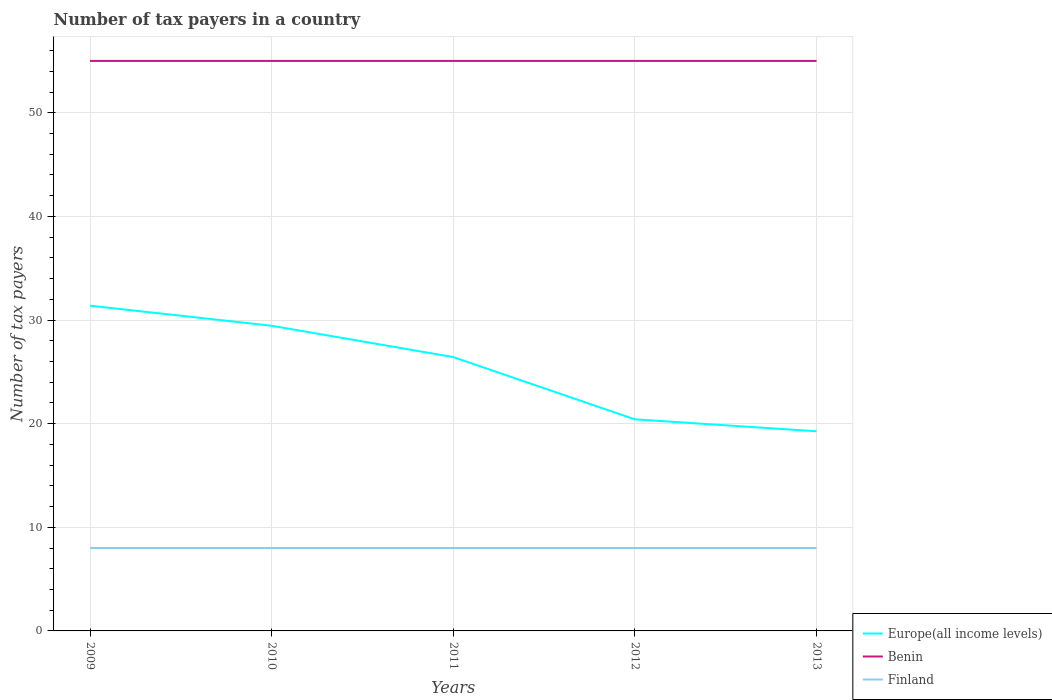How many different coloured lines are there?
Make the answer very short. 3. Across all years, what is the maximum number of tax payers in in Finland?
Give a very brief answer. 8. In which year was the number of tax payers in in Europe(all income levels) maximum?
Ensure brevity in your answer.  2013. What is the total number of tax payers in in Finland in the graph?
Provide a short and direct response. 0. Is the number of tax payers in in Benin strictly greater than the number of tax payers in in Finland over the years?
Make the answer very short. No. How many lines are there?
Ensure brevity in your answer.  3. How many years are there in the graph?
Offer a terse response. 5. Does the graph contain any zero values?
Make the answer very short. No. Does the graph contain grids?
Your response must be concise. Yes. How many legend labels are there?
Ensure brevity in your answer.  3. What is the title of the graph?
Your answer should be very brief. Number of tax payers in a country. What is the label or title of the X-axis?
Give a very brief answer. Years. What is the label or title of the Y-axis?
Keep it short and to the point. Number of tax payers. What is the Number of tax payers in Europe(all income levels) in 2009?
Make the answer very short. 31.38. What is the Number of tax payers of Benin in 2009?
Your answer should be very brief. 55. What is the Number of tax payers of Europe(all income levels) in 2010?
Give a very brief answer. 29.45. What is the Number of tax payers of Europe(all income levels) in 2011?
Offer a very short reply. 26.43. What is the Number of tax payers in Benin in 2011?
Ensure brevity in your answer.  55. What is the Number of tax payers of Finland in 2011?
Your response must be concise. 8. What is the Number of tax payers of Europe(all income levels) in 2012?
Your response must be concise. 20.42. What is the Number of tax payers of Europe(all income levels) in 2013?
Ensure brevity in your answer.  19.27. What is the Number of tax payers in Finland in 2013?
Make the answer very short. 8. Across all years, what is the maximum Number of tax payers of Europe(all income levels)?
Keep it short and to the point. 31.38. Across all years, what is the maximum Number of tax payers of Finland?
Your answer should be compact. 8. Across all years, what is the minimum Number of tax payers of Europe(all income levels)?
Ensure brevity in your answer.  19.27. What is the total Number of tax payers in Europe(all income levels) in the graph?
Offer a terse response. 126.94. What is the total Number of tax payers of Benin in the graph?
Make the answer very short. 275. What is the total Number of tax payers of Finland in the graph?
Provide a short and direct response. 40. What is the difference between the Number of tax payers of Europe(all income levels) in 2009 and that in 2010?
Provide a short and direct response. 1.94. What is the difference between the Number of tax payers of Benin in 2009 and that in 2010?
Make the answer very short. 0. What is the difference between the Number of tax payers in Finland in 2009 and that in 2010?
Your answer should be compact. 0. What is the difference between the Number of tax payers of Europe(all income levels) in 2009 and that in 2011?
Your answer should be very brief. 4.96. What is the difference between the Number of tax payers of Finland in 2009 and that in 2011?
Make the answer very short. 0. What is the difference between the Number of tax payers of Europe(all income levels) in 2009 and that in 2012?
Offer a terse response. 10.97. What is the difference between the Number of tax payers in Benin in 2009 and that in 2012?
Provide a succinct answer. 0. What is the difference between the Number of tax payers of Finland in 2009 and that in 2012?
Ensure brevity in your answer.  0. What is the difference between the Number of tax payers of Europe(all income levels) in 2009 and that in 2013?
Offer a terse response. 12.12. What is the difference between the Number of tax payers in Benin in 2009 and that in 2013?
Give a very brief answer. 0. What is the difference between the Number of tax payers of Europe(all income levels) in 2010 and that in 2011?
Offer a terse response. 3.02. What is the difference between the Number of tax payers of Benin in 2010 and that in 2011?
Give a very brief answer. 0. What is the difference between the Number of tax payers of Finland in 2010 and that in 2011?
Your answer should be very brief. 0. What is the difference between the Number of tax payers of Europe(all income levels) in 2010 and that in 2012?
Provide a short and direct response. 9.03. What is the difference between the Number of tax payers in Benin in 2010 and that in 2012?
Keep it short and to the point. 0. What is the difference between the Number of tax payers of Finland in 2010 and that in 2012?
Offer a very short reply. 0. What is the difference between the Number of tax payers of Europe(all income levels) in 2010 and that in 2013?
Your answer should be compact. 10.18. What is the difference between the Number of tax payers in Benin in 2010 and that in 2013?
Offer a very short reply. 0. What is the difference between the Number of tax payers of Europe(all income levels) in 2011 and that in 2012?
Keep it short and to the point. 6.01. What is the difference between the Number of tax payers of Benin in 2011 and that in 2012?
Keep it short and to the point. 0. What is the difference between the Number of tax payers of Finland in 2011 and that in 2012?
Your answer should be very brief. 0. What is the difference between the Number of tax payers in Europe(all income levels) in 2011 and that in 2013?
Keep it short and to the point. 7.16. What is the difference between the Number of tax payers of Benin in 2011 and that in 2013?
Provide a succinct answer. 0. What is the difference between the Number of tax payers of Finland in 2011 and that in 2013?
Keep it short and to the point. 0. What is the difference between the Number of tax payers in Europe(all income levels) in 2012 and that in 2013?
Your answer should be compact. 1.15. What is the difference between the Number of tax payers in Europe(all income levels) in 2009 and the Number of tax payers in Benin in 2010?
Keep it short and to the point. -23.62. What is the difference between the Number of tax payers in Europe(all income levels) in 2009 and the Number of tax payers in Finland in 2010?
Provide a succinct answer. 23.38. What is the difference between the Number of tax payers in Europe(all income levels) in 2009 and the Number of tax payers in Benin in 2011?
Offer a very short reply. -23.62. What is the difference between the Number of tax payers in Europe(all income levels) in 2009 and the Number of tax payers in Finland in 2011?
Keep it short and to the point. 23.38. What is the difference between the Number of tax payers in Benin in 2009 and the Number of tax payers in Finland in 2011?
Your answer should be very brief. 47. What is the difference between the Number of tax payers of Europe(all income levels) in 2009 and the Number of tax payers of Benin in 2012?
Offer a very short reply. -23.62. What is the difference between the Number of tax payers in Europe(all income levels) in 2009 and the Number of tax payers in Finland in 2012?
Offer a very short reply. 23.38. What is the difference between the Number of tax payers in Benin in 2009 and the Number of tax payers in Finland in 2012?
Your answer should be compact. 47. What is the difference between the Number of tax payers in Europe(all income levels) in 2009 and the Number of tax payers in Benin in 2013?
Provide a succinct answer. -23.62. What is the difference between the Number of tax payers in Europe(all income levels) in 2009 and the Number of tax payers in Finland in 2013?
Your answer should be very brief. 23.38. What is the difference between the Number of tax payers in Benin in 2009 and the Number of tax payers in Finland in 2013?
Provide a succinct answer. 47. What is the difference between the Number of tax payers of Europe(all income levels) in 2010 and the Number of tax payers of Benin in 2011?
Offer a terse response. -25.55. What is the difference between the Number of tax payers in Europe(all income levels) in 2010 and the Number of tax payers in Finland in 2011?
Keep it short and to the point. 21.45. What is the difference between the Number of tax payers of Benin in 2010 and the Number of tax payers of Finland in 2011?
Provide a short and direct response. 47. What is the difference between the Number of tax payers in Europe(all income levels) in 2010 and the Number of tax payers in Benin in 2012?
Make the answer very short. -25.55. What is the difference between the Number of tax payers of Europe(all income levels) in 2010 and the Number of tax payers of Finland in 2012?
Your response must be concise. 21.45. What is the difference between the Number of tax payers in Europe(all income levels) in 2010 and the Number of tax payers in Benin in 2013?
Your answer should be very brief. -25.55. What is the difference between the Number of tax payers of Europe(all income levels) in 2010 and the Number of tax payers of Finland in 2013?
Keep it short and to the point. 21.45. What is the difference between the Number of tax payers of Europe(all income levels) in 2011 and the Number of tax payers of Benin in 2012?
Give a very brief answer. -28.57. What is the difference between the Number of tax payers of Europe(all income levels) in 2011 and the Number of tax payers of Finland in 2012?
Offer a terse response. 18.43. What is the difference between the Number of tax payers in Europe(all income levels) in 2011 and the Number of tax payers in Benin in 2013?
Provide a succinct answer. -28.57. What is the difference between the Number of tax payers in Europe(all income levels) in 2011 and the Number of tax payers in Finland in 2013?
Provide a short and direct response. 18.43. What is the difference between the Number of tax payers in Europe(all income levels) in 2012 and the Number of tax payers in Benin in 2013?
Provide a succinct answer. -34.58. What is the difference between the Number of tax payers in Europe(all income levels) in 2012 and the Number of tax payers in Finland in 2013?
Make the answer very short. 12.42. What is the difference between the Number of tax payers of Benin in 2012 and the Number of tax payers of Finland in 2013?
Offer a terse response. 47. What is the average Number of tax payers in Europe(all income levels) per year?
Provide a short and direct response. 25.39. In the year 2009, what is the difference between the Number of tax payers of Europe(all income levels) and Number of tax payers of Benin?
Make the answer very short. -23.62. In the year 2009, what is the difference between the Number of tax payers of Europe(all income levels) and Number of tax payers of Finland?
Provide a short and direct response. 23.38. In the year 2009, what is the difference between the Number of tax payers in Benin and Number of tax payers in Finland?
Your response must be concise. 47. In the year 2010, what is the difference between the Number of tax payers in Europe(all income levels) and Number of tax payers in Benin?
Your answer should be very brief. -25.55. In the year 2010, what is the difference between the Number of tax payers of Europe(all income levels) and Number of tax payers of Finland?
Make the answer very short. 21.45. In the year 2011, what is the difference between the Number of tax payers of Europe(all income levels) and Number of tax payers of Benin?
Your response must be concise. -28.57. In the year 2011, what is the difference between the Number of tax payers in Europe(all income levels) and Number of tax payers in Finland?
Your answer should be very brief. 18.43. In the year 2011, what is the difference between the Number of tax payers of Benin and Number of tax payers of Finland?
Give a very brief answer. 47. In the year 2012, what is the difference between the Number of tax payers in Europe(all income levels) and Number of tax payers in Benin?
Your response must be concise. -34.58. In the year 2012, what is the difference between the Number of tax payers in Europe(all income levels) and Number of tax payers in Finland?
Your answer should be compact. 12.42. In the year 2013, what is the difference between the Number of tax payers of Europe(all income levels) and Number of tax payers of Benin?
Your response must be concise. -35.73. In the year 2013, what is the difference between the Number of tax payers in Europe(all income levels) and Number of tax payers in Finland?
Give a very brief answer. 11.27. What is the ratio of the Number of tax payers of Europe(all income levels) in 2009 to that in 2010?
Give a very brief answer. 1.07. What is the ratio of the Number of tax payers in Finland in 2009 to that in 2010?
Provide a succinct answer. 1. What is the ratio of the Number of tax payers of Europe(all income levels) in 2009 to that in 2011?
Offer a terse response. 1.19. What is the ratio of the Number of tax payers of Finland in 2009 to that in 2011?
Your response must be concise. 1. What is the ratio of the Number of tax payers of Europe(all income levels) in 2009 to that in 2012?
Make the answer very short. 1.54. What is the ratio of the Number of tax payers of Benin in 2009 to that in 2012?
Provide a short and direct response. 1. What is the ratio of the Number of tax payers of Finland in 2009 to that in 2012?
Your answer should be compact. 1. What is the ratio of the Number of tax payers in Europe(all income levels) in 2009 to that in 2013?
Make the answer very short. 1.63. What is the ratio of the Number of tax payers of Benin in 2009 to that in 2013?
Provide a short and direct response. 1. What is the ratio of the Number of tax payers in Finland in 2009 to that in 2013?
Your answer should be compact. 1. What is the ratio of the Number of tax payers of Europe(all income levels) in 2010 to that in 2011?
Ensure brevity in your answer.  1.11. What is the ratio of the Number of tax payers in Benin in 2010 to that in 2011?
Ensure brevity in your answer.  1. What is the ratio of the Number of tax payers in Finland in 2010 to that in 2011?
Your response must be concise. 1. What is the ratio of the Number of tax payers of Europe(all income levels) in 2010 to that in 2012?
Give a very brief answer. 1.44. What is the ratio of the Number of tax payers in Europe(all income levels) in 2010 to that in 2013?
Your answer should be very brief. 1.53. What is the ratio of the Number of tax payers of Benin in 2010 to that in 2013?
Keep it short and to the point. 1. What is the ratio of the Number of tax payers in Europe(all income levels) in 2011 to that in 2012?
Your response must be concise. 1.29. What is the ratio of the Number of tax payers in Europe(all income levels) in 2011 to that in 2013?
Keep it short and to the point. 1.37. What is the ratio of the Number of tax payers of Benin in 2011 to that in 2013?
Your answer should be compact. 1. What is the ratio of the Number of tax payers of Finland in 2011 to that in 2013?
Provide a succinct answer. 1. What is the ratio of the Number of tax payers in Europe(all income levels) in 2012 to that in 2013?
Give a very brief answer. 1.06. What is the ratio of the Number of tax payers of Benin in 2012 to that in 2013?
Your answer should be compact. 1. What is the ratio of the Number of tax payers in Finland in 2012 to that in 2013?
Offer a terse response. 1. What is the difference between the highest and the second highest Number of tax payers in Europe(all income levels)?
Make the answer very short. 1.94. What is the difference between the highest and the lowest Number of tax payers of Europe(all income levels)?
Provide a short and direct response. 12.12. What is the difference between the highest and the lowest Number of tax payers of Benin?
Offer a terse response. 0. 